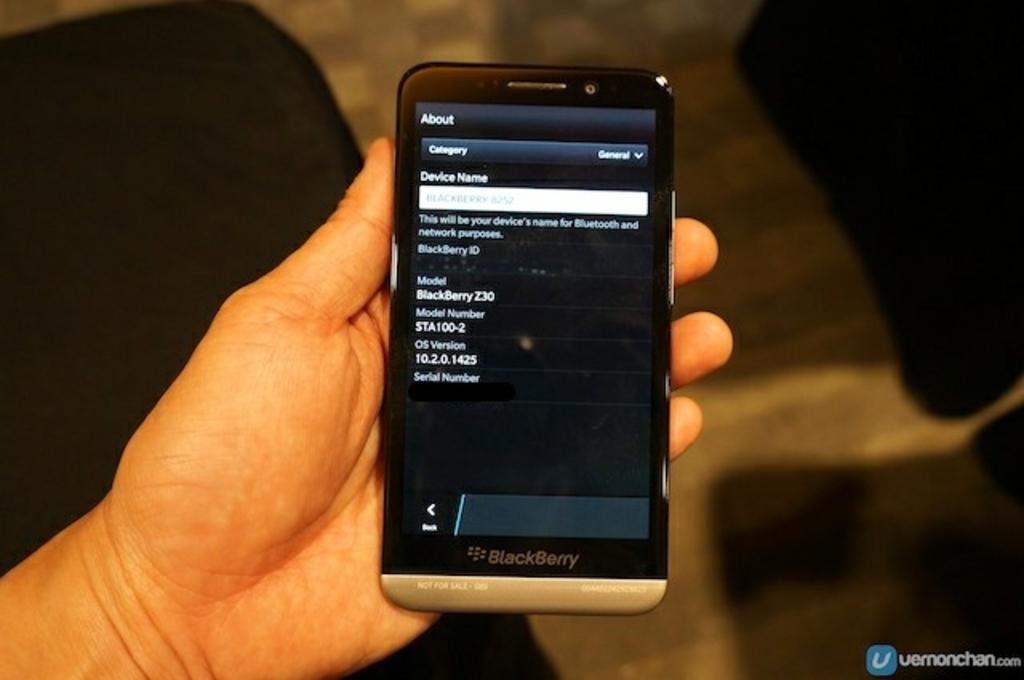What model is this phone?
Your response must be concise. Blackberry. 